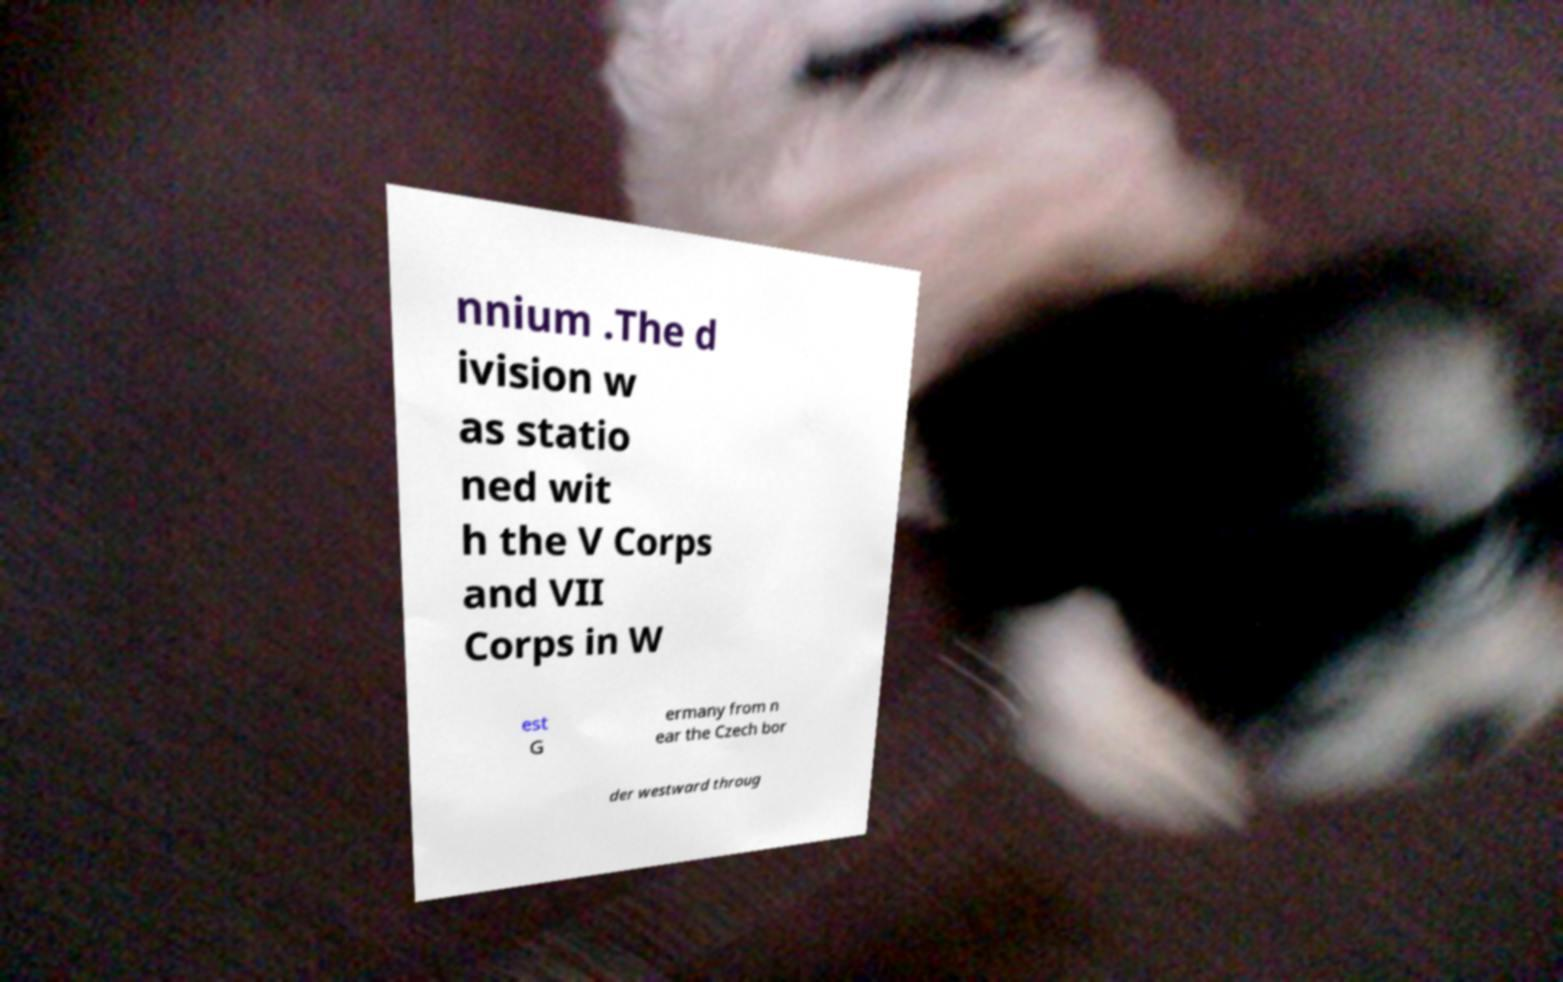There's text embedded in this image that I need extracted. Can you transcribe it verbatim? nnium .The d ivision w as statio ned wit h the V Corps and VII Corps in W est G ermany from n ear the Czech bor der westward throug 